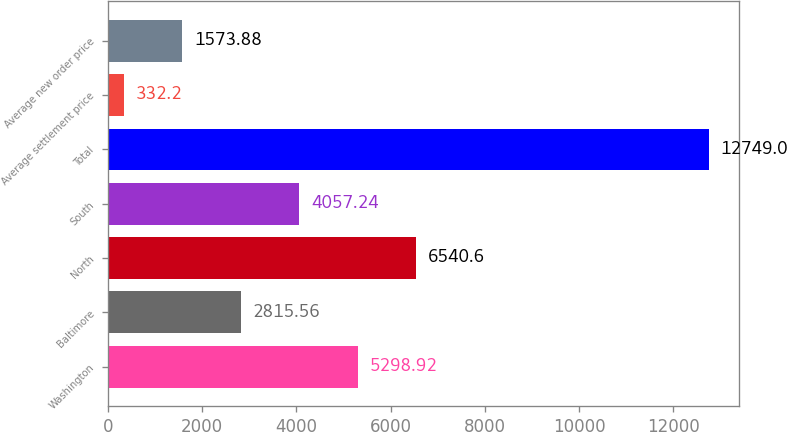Convert chart. <chart><loc_0><loc_0><loc_500><loc_500><bar_chart><fcel>Washington<fcel>Baltimore<fcel>North<fcel>South<fcel>Total<fcel>Average settlement price<fcel>Average new order price<nl><fcel>5298.92<fcel>2815.56<fcel>6540.6<fcel>4057.24<fcel>12749<fcel>332.2<fcel>1573.88<nl></chart> 